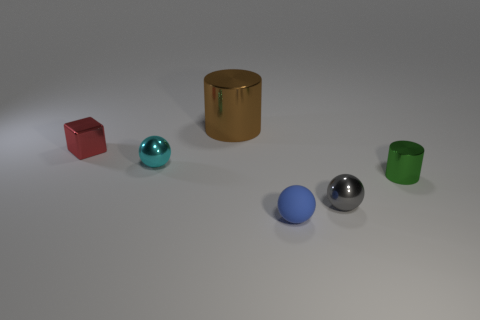Subtract all metal balls. How many balls are left? 1 Add 2 big objects. How many objects exist? 8 Subtract all cylinders. How many objects are left? 4 Subtract all tiny blocks. Subtract all rubber spheres. How many objects are left? 4 Add 2 tiny metal objects. How many tiny metal objects are left? 6 Add 4 tiny shiny spheres. How many tiny shiny spheres exist? 6 Subtract 1 gray spheres. How many objects are left? 5 